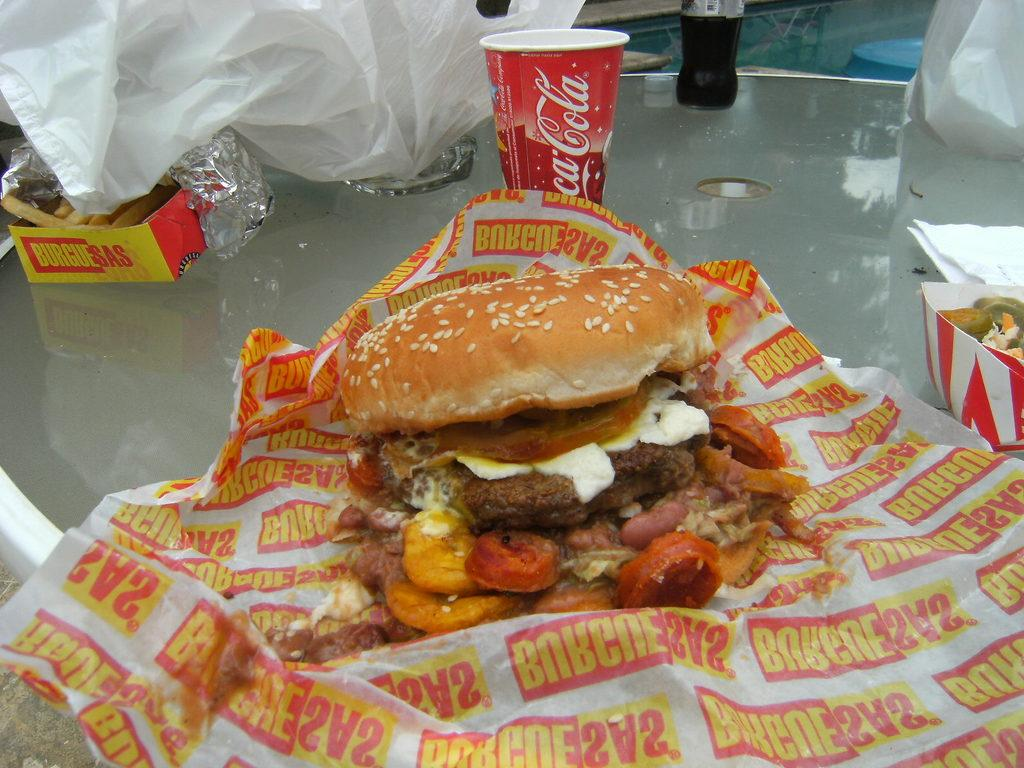What is the main food item on the paper on the table? There is a food item on a paper on a table, but the specific type of food is not mentioned in the facts. What other food items can be seen on the table? There are other food items on the table, but their specific types are not mentioned in the facts. What type of coverings are on the table? There are covers on the table, but their specific type is not mentioned in the facts. What is used for wiping or blowing one's nose on the table? Tissue paper is present on the table. What type of beverage is available on the table? There is a cool drink bottle on the table. What type of container is present on the table for holding a hot or cold beverage? There is a cup on the table. What can be seen in the background of the image? There are objects in the background of the image, but their specific types are not mentioned in the facts. How many pizzas are being attacked by the birds in the image? There are no pizzas or birds present in the image. How many chairs are visible in the image? The facts do not mention any chairs in the image. 